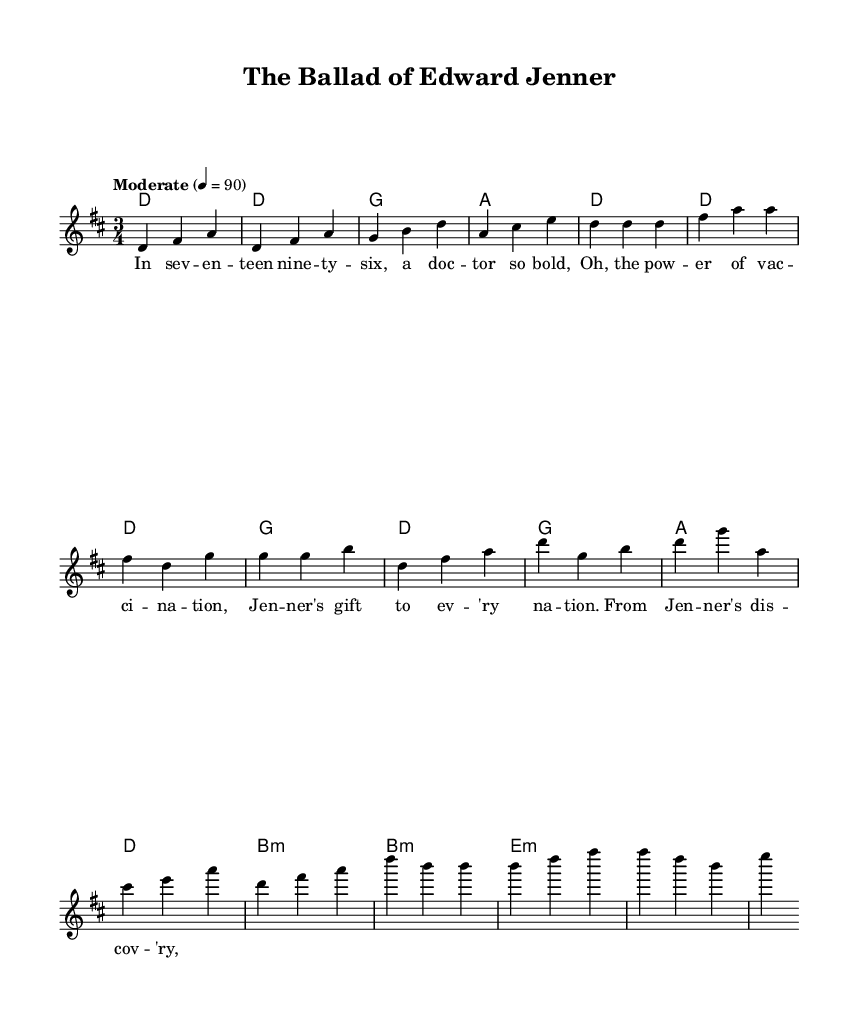What is the key signature of this music? The key signature is D major, which has two sharps (F# and C#). This is indicated at the beginning of the sheet music.
Answer: D major What is the time signature of this music? The time signature is 3/4, which is visible right at the beginning of the score. This indicates that there are three beats per measure, and the quarter note gets one beat.
Answer: 3/4 What is the tempo marking of this music? The tempo marking provided is "Moderate" at a rate of 90 beats per minute. This is generally recognized by the text indicated above the first measure.
Answer: Moderate 90 How many measures are there in the chorus? By counting the measures in the section labeled as "Chorus," there are four measures. This can be determined by visualizing the sections laid out in the music.
Answer: Four What type of folk narrative does this song recount? This song recounts the historical medical milestone of vaccination, specifically focusing on Edward Jenner's contributions. The lyrics detail his discoveries and their impact on society.
Answer: Vaccination What is the harmonic progression of the chorus? The harmonic progression in the chorus is D, G, A, D, as indicated by the chord symbols listed above the melody notes throughout that section.
Answer: D, G, A, D What historical figure is the focus of this ballad? The focus of this ballad is Edward Jenner, who is recognized for his pioneering work in vaccination. His name is mentioned in the lyrics.
Answer: Edward Jenner 